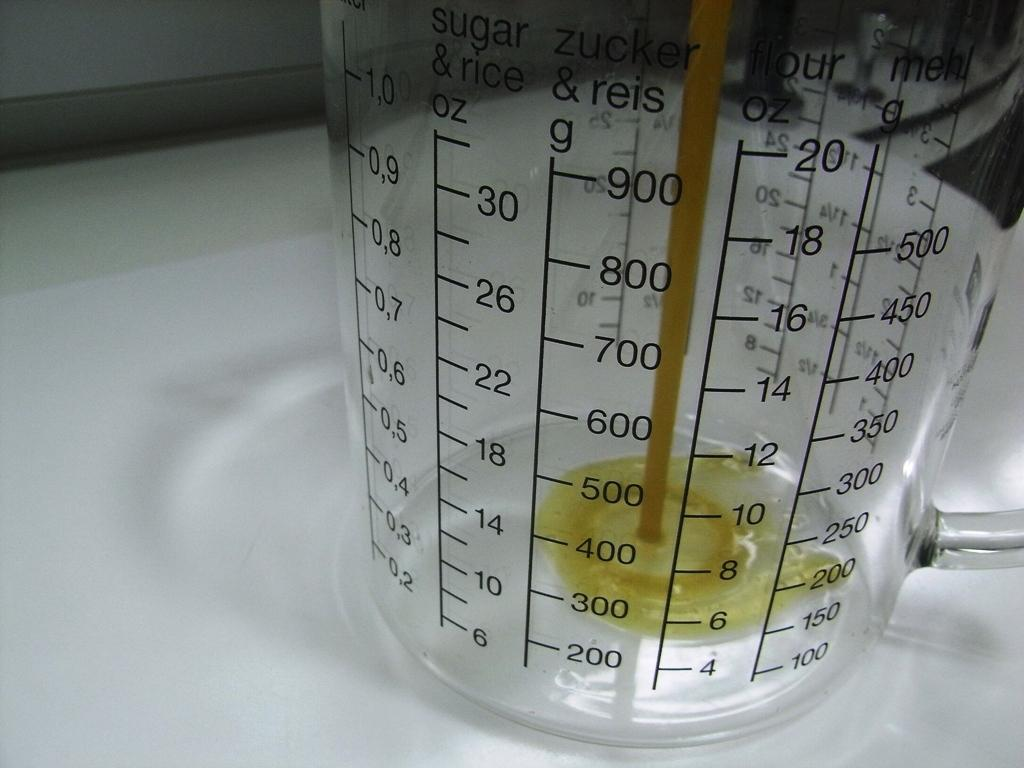Provide a one-sentence caption for the provided image. measuring cup for sugar, rice, flour, and zucker. 